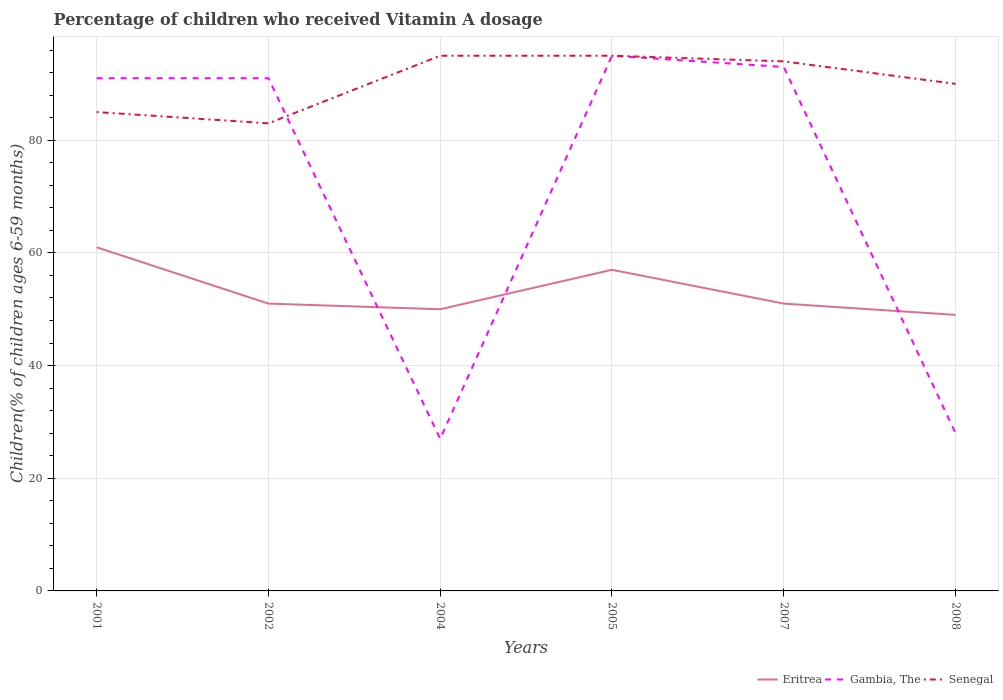How many different coloured lines are there?
Provide a succinct answer. 3. Does the line corresponding to Senegal intersect with the line corresponding to Gambia, The?
Make the answer very short. Yes. Is the number of lines equal to the number of legend labels?
Give a very brief answer. Yes. Across all years, what is the maximum percentage of children who received Vitamin A dosage in Gambia, The?
Keep it short and to the point. 27. In which year was the percentage of children who received Vitamin A dosage in Senegal maximum?
Ensure brevity in your answer.  2002. What is the difference between the highest and the lowest percentage of children who received Vitamin A dosage in Gambia, The?
Offer a terse response. 4. How many years are there in the graph?
Your response must be concise. 6. What is the difference between two consecutive major ticks on the Y-axis?
Your answer should be very brief. 20. Are the values on the major ticks of Y-axis written in scientific E-notation?
Your answer should be compact. No. Does the graph contain any zero values?
Offer a very short reply. No. How are the legend labels stacked?
Your answer should be very brief. Horizontal. What is the title of the graph?
Provide a succinct answer. Percentage of children who received Vitamin A dosage. Does "Andorra" appear as one of the legend labels in the graph?
Your answer should be compact. No. What is the label or title of the X-axis?
Provide a succinct answer. Years. What is the label or title of the Y-axis?
Offer a terse response. Children(% of children ages 6-59 months). What is the Children(% of children ages 6-59 months) of Gambia, The in 2001?
Keep it short and to the point. 91. What is the Children(% of children ages 6-59 months) in Senegal in 2001?
Provide a short and direct response. 85. What is the Children(% of children ages 6-59 months) in Gambia, The in 2002?
Offer a very short reply. 91. What is the Children(% of children ages 6-59 months) of Gambia, The in 2004?
Provide a short and direct response. 27. What is the Children(% of children ages 6-59 months) in Senegal in 2004?
Your answer should be very brief. 95. What is the Children(% of children ages 6-59 months) in Eritrea in 2005?
Keep it short and to the point. 57. What is the Children(% of children ages 6-59 months) in Gambia, The in 2005?
Your answer should be compact. 95. What is the Children(% of children ages 6-59 months) of Eritrea in 2007?
Give a very brief answer. 51. What is the Children(% of children ages 6-59 months) in Gambia, The in 2007?
Provide a short and direct response. 93. What is the Children(% of children ages 6-59 months) of Senegal in 2007?
Your response must be concise. 94. What is the Children(% of children ages 6-59 months) in Eritrea in 2008?
Your answer should be compact. 49. What is the Children(% of children ages 6-59 months) in Gambia, The in 2008?
Offer a very short reply. 28. What is the Children(% of children ages 6-59 months) of Senegal in 2008?
Make the answer very short. 90. Across all years, what is the maximum Children(% of children ages 6-59 months) of Eritrea?
Your response must be concise. 61. What is the total Children(% of children ages 6-59 months) of Eritrea in the graph?
Offer a terse response. 319. What is the total Children(% of children ages 6-59 months) in Gambia, The in the graph?
Provide a short and direct response. 425. What is the total Children(% of children ages 6-59 months) in Senegal in the graph?
Your answer should be compact. 542. What is the difference between the Children(% of children ages 6-59 months) of Eritrea in 2001 and that in 2004?
Ensure brevity in your answer.  11. What is the difference between the Children(% of children ages 6-59 months) in Senegal in 2001 and that in 2004?
Your response must be concise. -10. What is the difference between the Children(% of children ages 6-59 months) in Eritrea in 2001 and that in 2005?
Your response must be concise. 4. What is the difference between the Children(% of children ages 6-59 months) of Gambia, The in 2001 and that in 2005?
Provide a short and direct response. -4. What is the difference between the Children(% of children ages 6-59 months) in Senegal in 2001 and that in 2005?
Make the answer very short. -10. What is the difference between the Children(% of children ages 6-59 months) of Gambia, The in 2001 and that in 2007?
Your answer should be compact. -2. What is the difference between the Children(% of children ages 6-59 months) of Senegal in 2001 and that in 2008?
Provide a short and direct response. -5. What is the difference between the Children(% of children ages 6-59 months) in Eritrea in 2002 and that in 2004?
Ensure brevity in your answer.  1. What is the difference between the Children(% of children ages 6-59 months) of Gambia, The in 2002 and that in 2004?
Offer a terse response. 64. What is the difference between the Children(% of children ages 6-59 months) in Eritrea in 2002 and that in 2005?
Offer a terse response. -6. What is the difference between the Children(% of children ages 6-59 months) in Senegal in 2002 and that in 2007?
Make the answer very short. -11. What is the difference between the Children(% of children ages 6-59 months) of Gambia, The in 2002 and that in 2008?
Offer a terse response. 63. What is the difference between the Children(% of children ages 6-59 months) of Gambia, The in 2004 and that in 2005?
Your answer should be compact. -68. What is the difference between the Children(% of children ages 6-59 months) in Eritrea in 2004 and that in 2007?
Give a very brief answer. -1. What is the difference between the Children(% of children ages 6-59 months) in Gambia, The in 2004 and that in 2007?
Ensure brevity in your answer.  -66. What is the difference between the Children(% of children ages 6-59 months) of Eritrea in 2004 and that in 2008?
Keep it short and to the point. 1. What is the difference between the Children(% of children ages 6-59 months) in Senegal in 2004 and that in 2008?
Keep it short and to the point. 5. What is the difference between the Children(% of children ages 6-59 months) of Gambia, The in 2005 and that in 2007?
Offer a very short reply. 2. What is the difference between the Children(% of children ages 6-59 months) in Eritrea in 2005 and that in 2008?
Provide a succinct answer. 8. What is the difference between the Children(% of children ages 6-59 months) in Senegal in 2005 and that in 2008?
Ensure brevity in your answer.  5. What is the difference between the Children(% of children ages 6-59 months) in Eritrea in 2001 and the Children(% of children ages 6-59 months) in Gambia, The in 2004?
Give a very brief answer. 34. What is the difference between the Children(% of children ages 6-59 months) in Eritrea in 2001 and the Children(% of children ages 6-59 months) in Senegal in 2004?
Your answer should be compact. -34. What is the difference between the Children(% of children ages 6-59 months) of Eritrea in 2001 and the Children(% of children ages 6-59 months) of Gambia, The in 2005?
Give a very brief answer. -34. What is the difference between the Children(% of children ages 6-59 months) of Eritrea in 2001 and the Children(% of children ages 6-59 months) of Senegal in 2005?
Offer a very short reply. -34. What is the difference between the Children(% of children ages 6-59 months) in Gambia, The in 2001 and the Children(% of children ages 6-59 months) in Senegal in 2005?
Your response must be concise. -4. What is the difference between the Children(% of children ages 6-59 months) of Eritrea in 2001 and the Children(% of children ages 6-59 months) of Gambia, The in 2007?
Provide a short and direct response. -32. What is the difference between the Children(% of children ages 6-59 months) in Eritrea in 2001 and the Children(% of children ages 6-59 months) in Senegal in 2007?
Your answer should be compact. -33. What is the difference between the Children(% of children ages 6-59 months) in Gambia, The in 2001 and the Children(% of children ages 6-59 months) in Senegal in 2007?
Your answer should be compact. -3. What is the difference between the Children(% of children ages 6-59 months) in Eritrea in 2002 and the Children(% of children ages 6-59 months) in Gambia, The in 2004?
Your answer should be very brief. 24. What is the difference between the Children(% of children ages 6-59 months) of Eritrea in 2002 and the Children(% of children ages 6-59 months) of Senegal in 2004?
Keep it short and to the point. -44. What is the difference between the Children(% of children ages 6-59 months) in Gambia, The in 2002 and the Children(% of children ages 6-59 months) in Senegal in 2004?
Ensure brevity in your answer.  -4. What is the difference between the Children(% of children ages 6-59 months) in Eritrea in 2002 and the Children(% of children ages 6-59 months) in Gambia, The in 2005?
Offer a very short reply. -44. What is the difference between the Children(% of children ages 6-59 months) in Eritrea in 2002 and the Children(% of children ages 6-59 months) in Senegal in 2005?
Provide a short and direct response. -44. What is the difference between the Children(% of children ages 6-59 months) in Eritrea in 2002 and the Children(% of children ages 6-59 months) in Gambia, The in 2007?
Make the answer very short. -42. What is the difference between the Children(% of children ages 6-59 months) in Eritrea in 2002 and the Children(% of children ages 6-59 months) in Senegal in 2007?
Provide a succinct answer. -43. What is the difference between the Children(% of children ages 6-59 months) of Gambia, The in 2002 and the Children(% of children ages 6-59 months) of Senegal in 2007?
Your answer should be very brief. -3. What is the difference between the Children(% of children ages 6-59 months) of Eritrea in 2002 and the Children(% of children ages 6-59 months) of Senegal in 2008?
Make the answer very short. -39. What is the difference between the Children(% of children ages 6-59 months) of Eritrea in 2004 and the Children(% of children ages 6-59 months) of Gambia, The in 2005?
Offer a terse response. -45. What is the difference between the Children(% of children ages 6-59 months) in Eritrea in 2004 and the Children(% of children ages 6-59 months) in Senegal in 2005?
Ensure brevity in your answer.  -45. What is the difference between the Children(% of children ages 6-59 months) in Gambia, The in 2004 and the Children(% of children ages 6-59 months) in Senegal in 2005?
Provide a succinct answer. -68. What is the difference between the Children(% of children ages 6-59 months) in Eritrea in 2004 and the Children(% of children ages 6-59 months) in Gambia, The in 2007?
Keep it short and to the point. -43. What is the difference between the Children(% of children ages 6-59 months) of Eritrea in 2004 and the Children(% of children ages 6-59 months) of Senegal in 2007?
Offer a terse response. -44. What is the difference between the Children(% of children ages 6-59 months) of Gambia, The in 2004 and the Children(% of children ages 6-59 months) of Senegal in 2007?
Your answer should be compact. -67. What is the difference between the Children(% of children ages 6-59 months) in Gambia, The in 2004 and the Children(% of children ages 6-59 months) in Senegal in 2008?
Offer a very short reply. -63. What is the difference between the Children(% of children ages 6-59 months) of Eritrea in 2005 and the Children(% of children ages 6-59 months) of Gambia, The in 2007?
Ensure brevity in your answer.  -36. What is the difference between the Children(% of children ages 6-59 months) of Eritrea in 2005 and the Children(% of children ages 6-59 months) of Senegal in 2007?
Your response must be concise. -37. What is the difference between the Children(% of children ages 6-59 months) of Gambia, The in 2005 and the Children(% of children ages 6-59 months) of Senegal in 2007?
Offer a very short reply. 1. What is the difference between the Children(% of children ages 6-59 months) in Eritrea in 2005 and the Children(% of children ages 6-59 months) in Senegal in 2008?
Give a very brief answer. -33. What is the difference between the Children(% of children ages 6-59 months) of Gambia, The in 2005 and the Children(% of children ages 6-59 months) of Senegal in 2008?
Your answer should be compact. 5. What is the difference between the Children(% of children ages 6-59 months) in Eritrea in 2007 and the Children(% of children ages 6-59 months) in Gambia, The in 2008?
Your answer should be compact. 23. What is the difference between the Children(% of children ages 6-59 months) of Eritrea in 2007 and the Children(% of children ages 6-59 months) of Senegal in 2008?
Offer a terse response. -39. What is the difference between the Children(% of children ages 6-59 months) in Gambia, The in 2007 and the Children(% of children ages 6-59 months) in Senegal in 2008?
Offer a very short reply. 3. What is the average Children(% of children ages 6-59 months) of Eritrea per year?
Provide a short and direct response. 53.17. What is the average Children(% of children ages 6-59 months) in Gambia, The per year?
Offer a terse response. 70.83. What is the average Children(% of children ages 6-59 months) of Senegal per year?
Give a very brief answer. 90.33. In the year 2001, what is the difference between the Children(% of children ages 6-59 months) in Eritrea and Children(% of children ages 6-59 months) in Gambia, The?
Make the answer very short. -30. In the year 2001, what is the difference between the Children(% of children ages 6-59 months) in Eritrea and Children(% of children ages 6-59 months) in Senegal?
Your answer should be very brief. -24. In the year 2002, what is the difference between the Children(% of children ages 6-59 months) in Eritrea and Children(% of children ages 6-59 months) in Gambia, The?
Your response must be concise. -40. In the year 2002, what is the difference between the Children(% of children ages 6-59 months) of Eritrea and Children(% of children ages 6-59 months) of Senegal?
Offer a very short reply. -32. In the year 2004, what is the difference between the Children(% of children ages 6-59 months) in Eritrea and Children(% of children ages 6-59 months) in Senegal?
Offer a very short reply. -45. In the year 2004, what is the difference between the Children(% of children ages 6-59 months) in Gambia, The and Children(% of children ages 6-59 months) in Senegal?
Give a very brief answer. -68. In the year 2005, what is the difference between the Children(% of children ages 6-59 months) of Eritrea and Children(% of children ages 6-59 months) of Gambia, The?
Your answer should be very brief. -38. In the year 2005, what is the difference between the Children(% of children ages 6-59 months) in Eritrea and Children(% of children ages 6-59 months) in Senegal?
Your answer should be compact. -38. In the year 2007, what is the difference between the Children(% of children ages 6-59 months) in Eritrea and Children(% of children ages 6-59 months) in Gambia, The?
Your response must be concise. -42. In the year 2007, what is the difference between the Children(% of children ages 6-59 months) of Eritrea and Children(% of children ages 6-59 months) of Senegal?
Offer a very short reply. -43. In the year 2008, what is the difference between the Children(% of children ages 6-59 months) in Eritrea and Children(% of children ages 6-59 months) in Senegal?
Keep it short and to the point. -41. In the year 2008, what is the difference between the Children(% of children ages 6-59 months) in Gambia, The and Children(% of children ages 6-59 months) in Senegal?
Make the answer very short. -62. What is the ratio of the Children(% of children ages 6-59 months) in Eritrea in 2001 to that in 2002?
Your answer should be compact. 1.2. What is the ratio of the Children(% of children ages 6-59 months) in Senegal in 2001 to that in 2002?
Provide a succinct answer. 1.02. What is the ratio of the Children(% of children ages 6-59 months) of Eritrea in 2001 to that in 2004?
Offer a terse response. 1.22. What is the ratio of the Children(% of children ages 6-59 months) of Gambia, The in 2001 to that in 2004?
Provide a succinct answer. 3.37. What is the ratio of the Children(% of children ages 6-59 months) of Senegal in 2001 to that in 2004?
Your response must be concise. 0.89. What is the ratio of the Children(% of children ages 6-59 months) of Eritrea in 2001 to that in 2005?
Your answer should be compact. 1.07. What is the ratio of the Children(% of children ages 6-59 months) of Gambia, The in 2001 to that in 2005?
Ensure brevity in your answer.  0.96. What is the ratio of the Children(% of children ages 6-59 months) of Senegal in 2001 to that in 2005?
Offer a terse response. 0.89. What is the ratio of the Children(% of children ages 6-59 months) of Eritrea in 2001 to that in 2007?
Your answer should be very brief. 1.2. What is the ratio of the Children(% of children ages 6-59 months) of Gambia, The in 2001 to that in 2007?
Offer a terse response. 0.98. What is the ratio of the Children(% of children ages 6-59 months) in Senegal in 2001 to that in 2007?
Make the answer very short. 0.9. What is the ratio of the Children(% of children ages 6-59 months) in Eritrea in 2001 to that in 2008?
Ensure brevity in your answer.  1.24. What is the ratio of the Children(% of children ages 6-59 months) in Gambia, The in 2001 to that in 2008?
Ensure brevity in your answer.  3.25. What is the ratio of the Children(% of children ages 6-59 months) of Senegal in 2001 to that in 2008?
Your response must be concise. 0.94. What is the ratio of the Children(% of children ages 6-59 months) in Eritrea in 2002 to that in 2004?
Provide a succinct answer. 1.02. What is the ratio of the Children(% of children ages 6-59 months) of Gambia, The in 2002 to that in 2004?
Provide a short and direct response. 3.37. What is the ratio of the Children(% of children ages 6-59 months) of Senegal in 2002 to that in 2004?
Your answer should be compact. 0.87. What is the ratio of the Children(% of children ages 6-59 months) of Eritrea in 2002 to that in 2005?
Your response must be concise. 0.89. What is the ratio of the Children(% of children ages 6-59 months) in Gambia, The in 2002 to that in 2005?
Provide a short and direct response. 0.96. What is the ratio of the Children(% of children ages 6-59 months) of Senegal in 2002 to that in 2005?
Make the answer very short. 0.87. What is the ratio of the Children(% of children ages 6-59 months) of Eritrea in 2002 to that in 2007?
Provide a succinct answer. 1. What is the ratio of the Children(% of children ages 6-59 months) in Gambia, The in 2002 to that in 2007?
Make the answer very short. 0.98. What is the ratio of the Children(% of children ages 6-59 months) of Senegal in 2002 to that in 2007?
Ensure brevity in your answer.  0.88. What is the ratio of the Children(% of children ages 6-59 months) of Eritrea in 2002 to that in 2008?
Provide a succinct answer. 1.04. What is the ratio of the Children(% of children ages 6-59 months) in Senegal in 2002 to that in 2008?
Ensure brevity in your answer.  0.92. What is the ratio of the Children(% of children ages 6-59 months) of Eritrea in 2004 to that in 2005?
Give a very brief answer. 0.88. What is the ratio of the Children(% of children ages 6-59 months) in Gambia, The in 2004 to that in 2005?
Provide a succinct answer. 0.28. What is the ratio of the Children(% of children ages 6-59 months) of Senegal in 2004 to that in 2005?
Offer a terse response. 1. What is the ratio of the Children(% of children ages 6-59 months) in Eritrea in 2004 to that in 2007?
Your answer should be very brief. 0.98. What is the ratio of the Children(% of children ages 6-59 months) of Gambia, The in 2004 to that in 2007?
Your response must be concise. 0.29. What is the ratio of the Children(% of children ages 6-59 months) of Senegal in 2004 to that in 2007?
Your response must be concise. 1.01. What is the ratio of the Children(% of children ages 6-59 months) in Eritrea in 2004 to that in 2008?
Provide a short and direct response. 1.02. What is the ratio of the Children(% of children ages 6-59 months) in Senegal in 2004 to that in 2008?
Make the answer very short. 1.06. What is the ratio of the Children(% of children ages 6-59 months) in Eritrea in 2005 to that in 2007?
Provide a short and direct response. 1.12. What is the ratio of the Children(% of children ages 6-59 months) of Gambia, The in 2005 to that in 2007?
Provide a short and direct response. 1.02. What is the ratio of the Children(% of children ages 6-59 months) in Senegal in 2005 to that in 2007?
Give a very brief answer. 1.01. What is the ratio of the Children(% of children ages 6-59 months) of Eritrea in 2005 to that in 2008?
Offer a terse response. 1.16. What is the ratio of the Children(% of children ages 6-59 months) of Gambia, The in 2005 to that in 2008?
Offer a terse response. 3.39. What is the ratio of the Children(% of children ages 6-59 months) of Senegal in 2005 to that in 2008?
Provide a succinct answer. 1.06. What is the ratio of the Children(% of children ages 6-59 months) in Eritrea in 2007 to that in 2008?
Make the answer very short. 1.04. What is the ratio of the Children(% of children ages 6-59 months) of Gambia, The in 2007 to that in 2008?
Provide a short and direct response. 3.32. What is the ratio of the Children(% of children ages 6-59 months) of Senegal in 2007 to that in 2008?
Your answer should be compact. 1.04. What is the difference between the highest and the second highest Children(% of children ages 6-59 months) of Gambia, The?
Make the answer very short. 2. What is the difference between the highest and the lowest Children(% of children ages 6-59 months) in Eritrea?
Keep it short and to the point. 12. What is the difference between the highest and the lowest Children(% of children ages 6-59 months) in Gambia, The?
Your response must be concise. 68. What is the difference between the highest and the lowest Children(% of children ages 6-59 months) of Senegal?
Give a very brief answer. 12. 